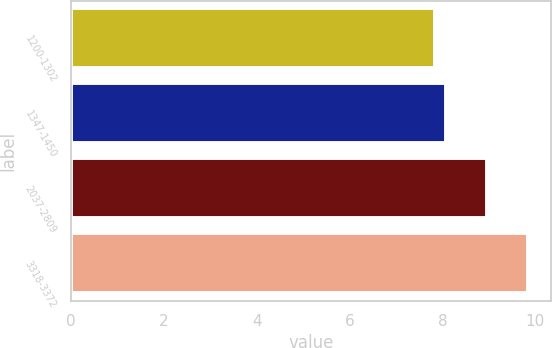Convert chart to OTSL. <chart><loc_0><loc_0><loc_500><loc_500><bar_chart><fcel>1200-1302<fcel>1347-1450<fcel>2037-2809<fcel>3318-3372<nl><fcel>7.84<fcel>8.08<fcel>8.97<fcel>9.84<nl></chart> 